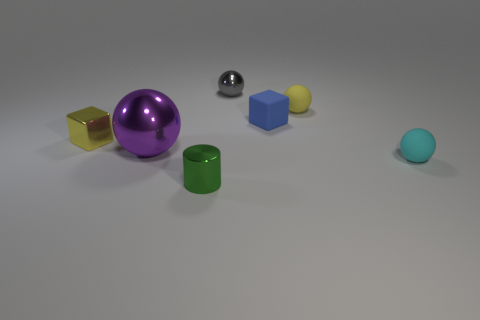Is the number of small matte cubes that are to the right of the green thing less than the number of cyan spheres?
Provide a succinct answer. No. What shape is the metallic thing that is in front of the cyan rubber thing?
Provide a short and direct response. Cylinder. There is a green object that is the same size as the yellow matte thing; what shape is it?
Give a very brief answer. Cylinder. Is there another metal object of the same shape as the cyan thing?
Provide a succinct answer. Yes. Does the yellow object right of the big purple shiny thing have the same shape as the tiny thing on the left side of the large thing?
Your response must be concise. No. There is a gray object that is the same size as the metal cylinder; what material is it?
Provide a succinct answer. Metal. What number of other things are the same material as the tiny blue thing?
Your answer should be compact. 2. The tiny shiny thing behind the tiny yellow thing that is on the right side of the big purple shiny thing is what shape?
Give a very brief answer. Sphere. How many things are either big gray metal cubes or metallic balls that are on the right side of the purple ball?
Make the answer very short. 1. What number of other objects are the same color as the small metal cylinder?
Your answer should be compact. 0. 